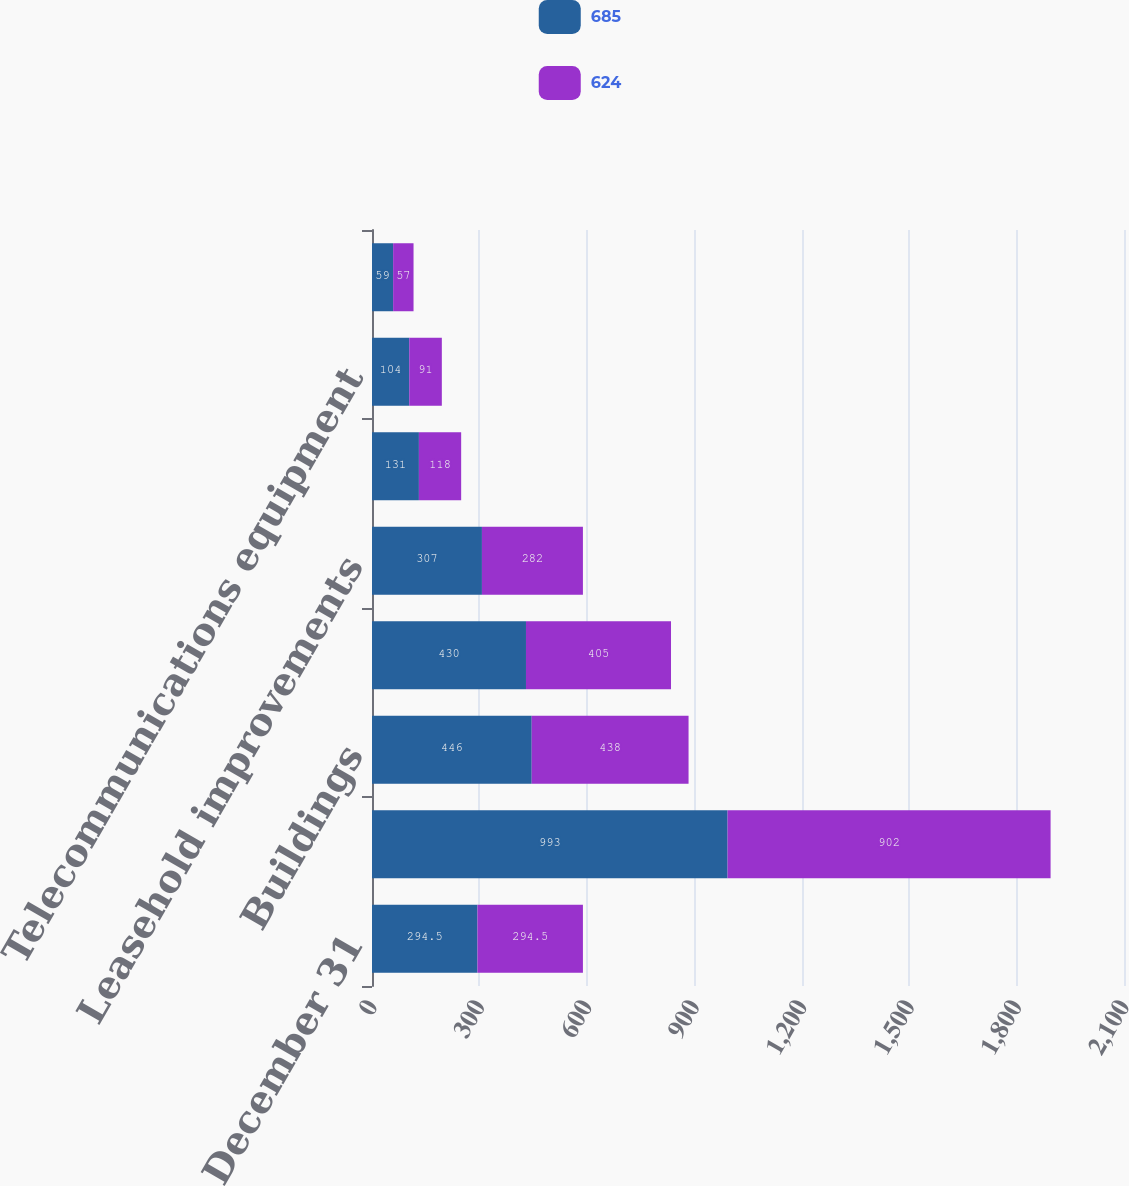Convert chart. <chart><loc_0><loc_0><loc_500><loc_500><stacked_bar_chart><ecel><fcel>December 31<fcel>Software<fcel>Buildings<fcel>Information technology<fcel>Leasehold improvements<fcel>Furniture and equipment<fcel>Telecommunications equipment<fcel>Land<nl><fcel>685<fcel>294.5<fcel>993<fcel>446<fcel>430<fcel>307<fcel>131<fcel>104<fcel>59<nl><fcel>624<fcel>294.5<fcel>902<fcel>438<fcel>405<fcel>282<fcel>118<fcel>91<fcel>57<nl></chart> 